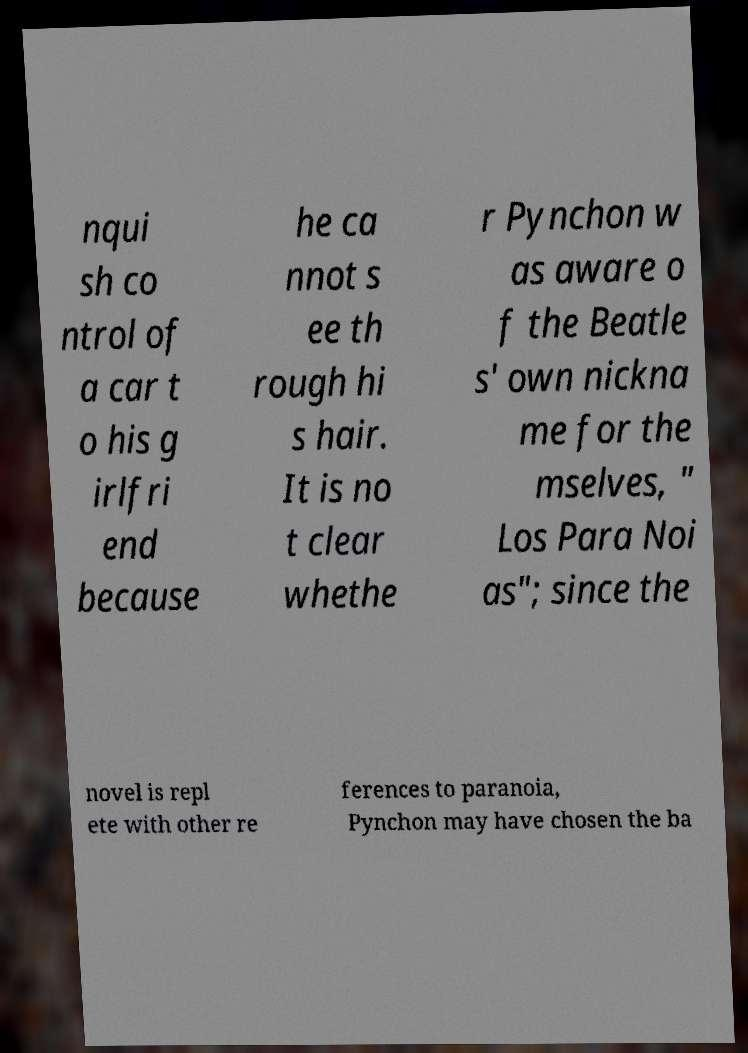Please read and relay the text visible in this image. What does it say? nqui sh co ntrol of a car t o his g irlfri end because he ca nnot s ee th rough hi s hair. It is no t clear whethe r Pynchon w as aware o f the Beatle s' own nickna me for the mselves, " Los Para Noi as"; since the novel is repl ete with other re ferences to paranoia, Pynchon may have chosen the ba 